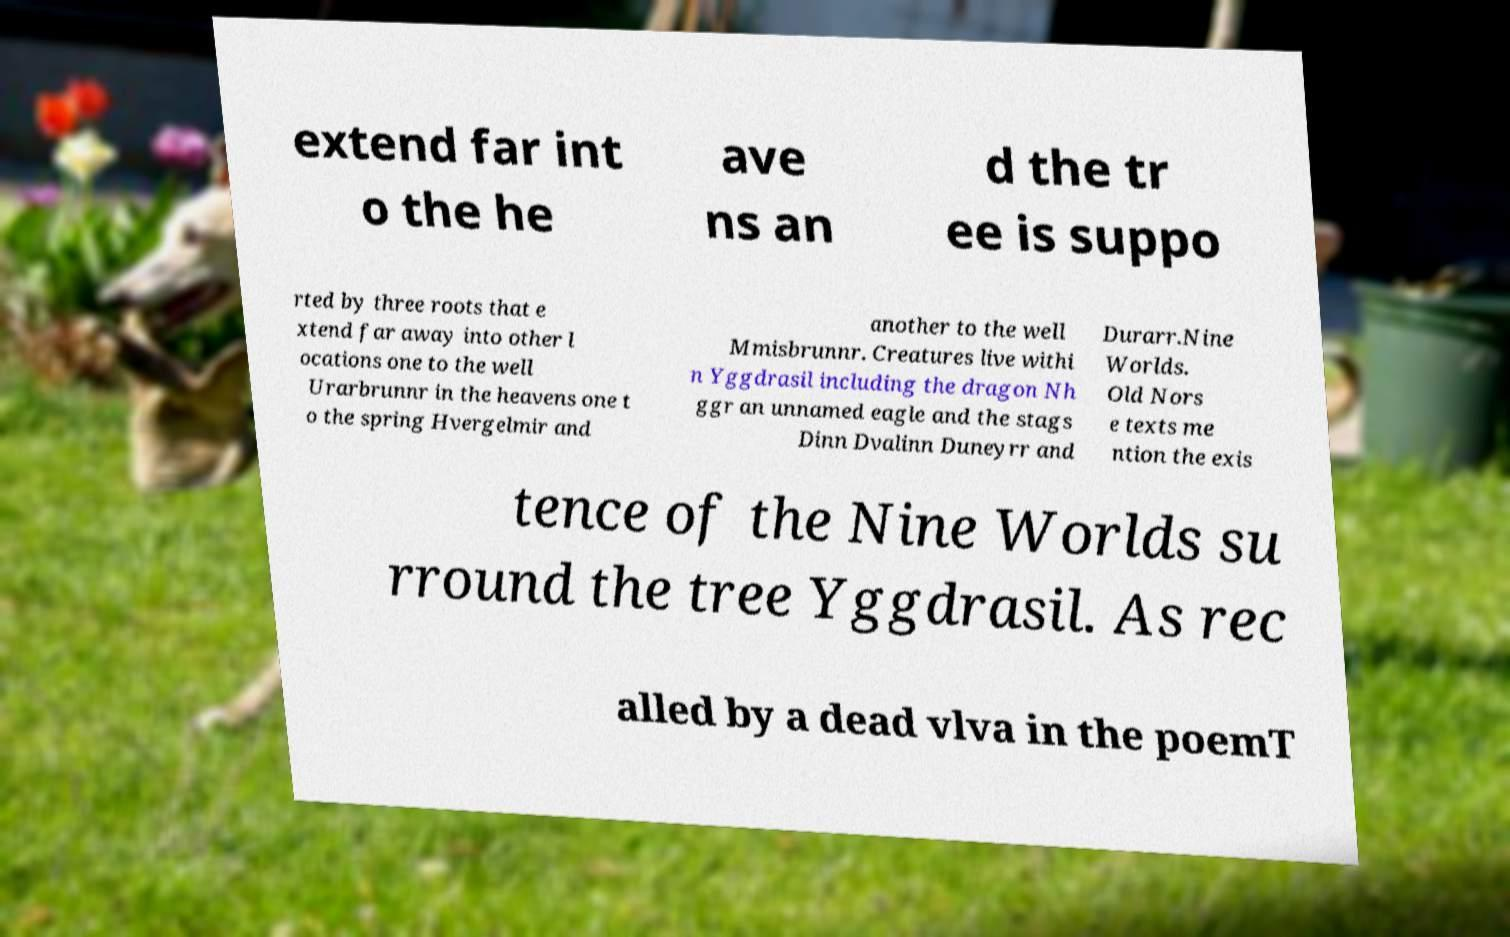Could you extract and type out the text from this image? extend far int o the he ave ns an d the tr ee is suppo rted by three roots that e xtend far away into other l ocations one to the well Urarbrunnr in the heavens one t o the spring Hvergelmir and another to the well Mmisbrunnr. Creatures live withi n Yggdrasil including the dragon Nh ggr an unnamed eagle and the stags Dinn Dvalinn Duneyrr and Durarr.Nine Worlds. Old Nors e texts me ntion the exis tence of the Nine Worlds su rround the tree Yggdrasil. As rec alled by a dead vlva in the poemT 